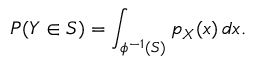Convert formula to latex. <formula><loc_0><loc_0><loc_500><loc_500>P ( Y \in S ) = \int _ { \phi ^ { - 1 } ( S ) } p _ { X } ( x ) \, d x .</formula> 